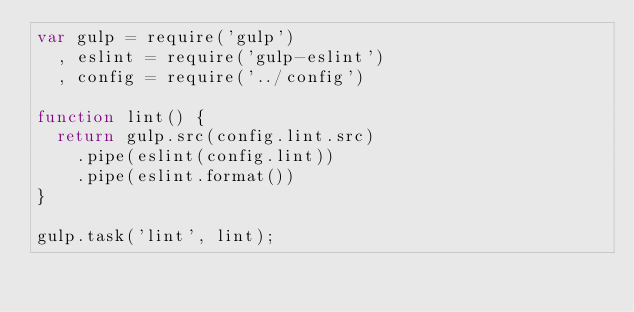<code> <loc_0><loc_0><loc_500><loc_500><_JavaScript_>var gulp = require('gulp')
  , eslint = require('gulp-eslint')
  , config = require('../config')

function lint() {
  return gulp.src(config.lint.src)
    .pipe(eslint(config.lint))
    .pipe(eslint.format())
}

gulp.task('lint', lint);
</code> 